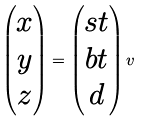Convert formula to latex. <formula><loc_0><loc_0><loc_500><loc_500>\begin{pmatrix} x \\ y \\ z \end{pmatrix} = \begin{pmatrix} s t \\ b t \\ d \end{pmatrix} v</formula> 